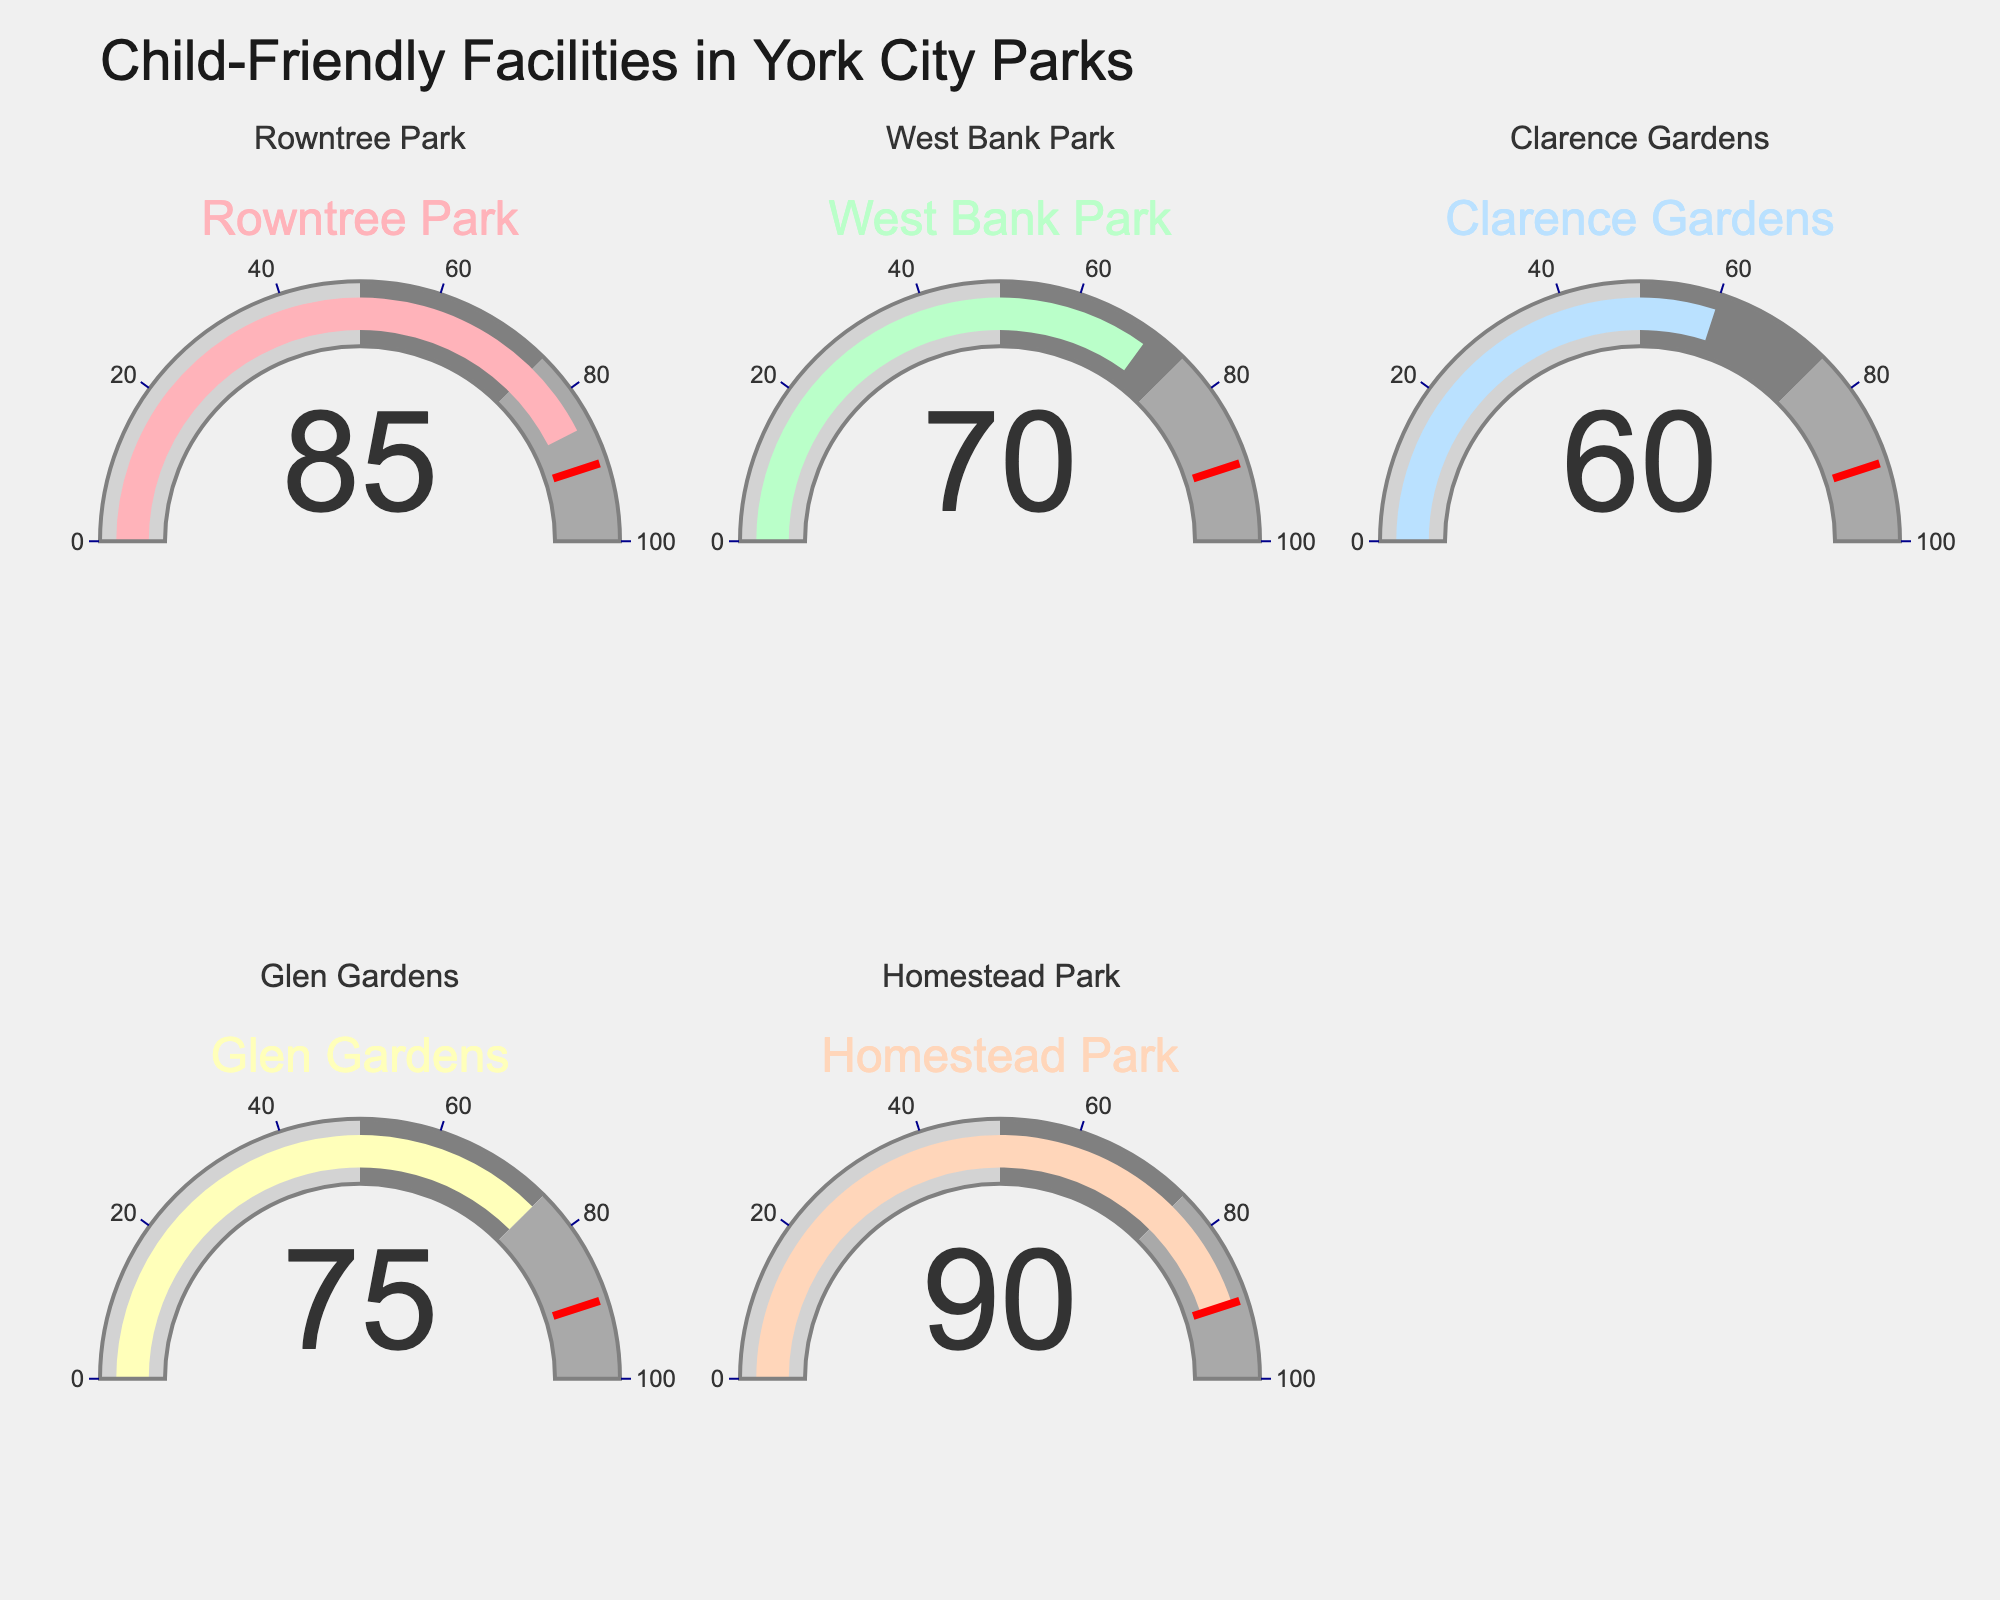What is the title of the figure? The title is at the top of the figure and reads "Child-Friendly Facilities in York City Parks".
Answer: Child-Friendly Facilities in York City Parks What park has the highest percentage of child-friendly facilities? Look at the gauge charts and see that the highest value is 90%, which corresponds to Homestead Park.
Answer: Homestead Park What is the average percentage of child-friendly facilities across the parks? Sum the percentages: 85 + 70 + 60 + 75 + 90 = 380. Then divide by the number of parks (5): 380 / 5 = 76.
Answer: 76 Which park has a percentage of child-friendly facilities closest to the average? The average is 76%. Compare the parks' percentages: 85, 70, 60, 75, 90. The closest is 75% from Glen Gardens.
Answer: Glen Gardens Which parks have a child-friendly facility percentage below 75%? Look for gauges below 75%: West Bank Park (70%) and Clarence Gardens (60%).
Answer: West Bank Park, Clarence Gardens What is the percentage range covered by the gray color on the gauge? The gauge chart uses gray from 50% to 75%.
Answer: 50%-75% Does Homestead Park exceed the threshold value marked on the gauge chart? The threshold is marked at 90% with a red line. Homestead Park has 90%, which meets but does not exceed the threshold.
Answer: No How many parks have a percentage of child-friendly facilities greater than 80%? Count the parks with percentages higher than 80%: Rowntree Park (85%) and Homestead Park (90%).
Answer: 2 What is the difference in percentage between Rowntree Park and Clarence Gardens? Subtract the smaller percentage from the larger percentage: 85% - 60% = 25%.
Answer: 25% Which park has the second-highest percentage of child-friendly facilities? Rank the percentages: 90% (Homestead Park), 85% (Rowntree Park), 75% (Glen Gardens), 70% (West Bank Park), 60% (Clarence Gardens). The second-highest is Rowntree Park with 85%.
Answer: Rowntree Park 